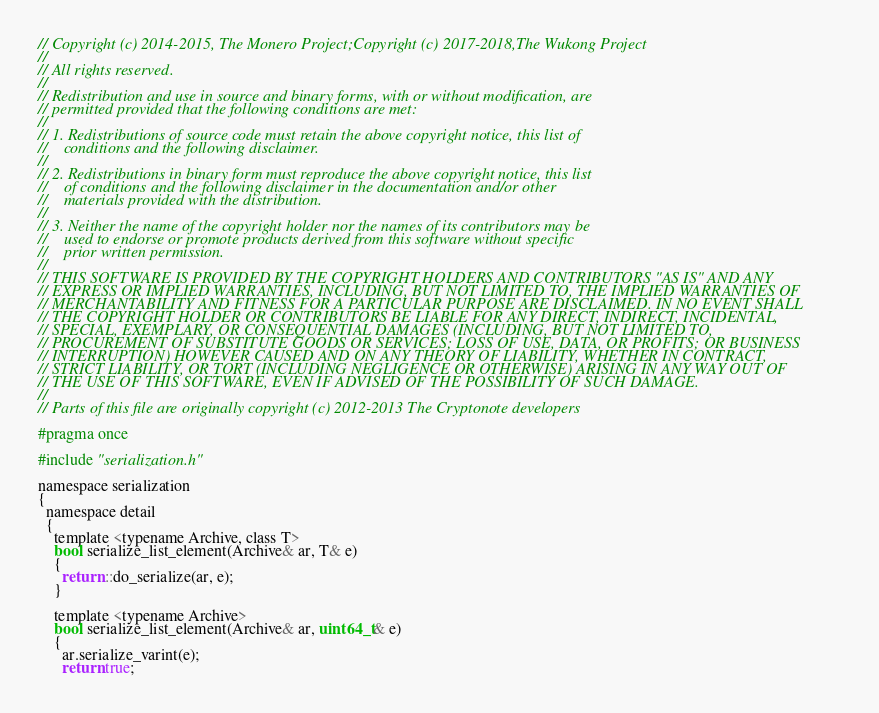<code> <loc_0><loc_0><loc_500><loc_500><_C_>// Copyright (c) 2014-2015, The Monero Project;Copyright (c) 2017-2018,The Wukong Project
// 
// All rights reserved.
// 
// Redistribution and use in source and binary forms, with or without modification, are
// permitted provided that the following conditions are met:
// 
// 1. Redistributions of source code must retain the above copyright notice, this list of
//    conditions and the following disclaimer.
// 
// 2. Redistributions in binary form must reproduce the above copyright notice, this list
//    of conditions and the following disclaimer in the documentation and/or other
//    materials provided with the distribution.
// 
// 3. Neither the name of the copyright holder nor the names of its contributors may be
//    used to endorse or promote products derived from this software without specific
//    prior written permission.
// 
// THIS SOFTWARE IS PROVIDED BY THE COPYRIGHT HOLDERS AND CONTRIBUTORS "AS IS" AND ANY
// EXPRESS OR IMPLIED WARRANTIES, INCLUDING, BUT NOT LIMITED TO, THE IMPLIED WARRANTIES OF
// MERCHANTABILITY AND FITNESS FOR A PARTICULAR PURPOSE ARE DISCLAIMED. IN NO EVENT SHALL
// THE COPYRIGHT HOLDER OR CONTRIBUTORS BE LIABLE FOR ANY DIRECT, INDIRECT, INCIDENTAL,
// SPECIAL, EXEMPLARY, OR CONSEQUENTIAL DAMAGES (INCLUDING, BUT NOT LIMITED TO,
// PROCUREMENT OF SUBSTITUTE GOODS OR SERVICES; LOSS OF USE, DATA, OR PROFITS; OR BUSINESS
// INTERRUPTION) HOWEVER CAUSED AND ON ANY THEORY OF LIABILITY, WHETHER IN CONTRACT,
// STRICT LIABILITY, OR TORT (INCLUDING NEGLIGENCE OR OTHERWISE) ARISING IN ANY WAY OUT OF
// THE USE OF THIS SOFTWARE, EVEN IF ADVISED OF THE POSSIBILITY OF SUCH DAMAGE.
// 
// Parts of this file are originally copyright (c) 2012-2013 The Cryptonote developers

#pragma once

#include "serialization.h"

namespace serialization
{
  namespace detail
  {
    template <typename Archive, class T>
    bool serialize_list_element(Archive& ar, T& e)
    {
      return ::do_serialize(ar, e);
    }

    template <typename Archive>
    bool serialize_list_element(Archive& ar, uint64_t& e)
    {
      ar.serialize_varint(e);
      return true;</code> 